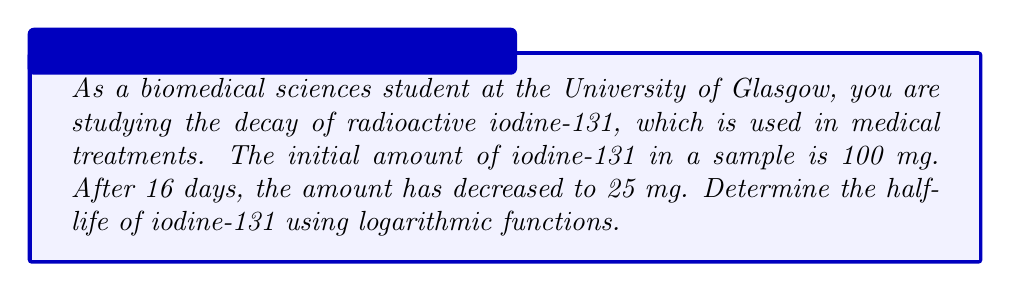Provide a solution to this math problem. To solve this problem, we'll use the exponential decay formula and logarithms:

1) The exponential decay formula is:
   $$A(t) = A_0 \cdot e^{-\lambda t}$$
   where $A(t)$ is the amount at time $t$, $A_0$ is the initial amount, $\lambda$ is the decay constant, and $t$ is time.

2) We know:
   $A_0 = 100$ mg
   $A(16) = 25$ mg
   $t = 16$ days

3) Substitute these values into the formula:
   $$25 = 100 \cdot e^{-16\lambda}$$

4) Divide both sides by 100:
   $$0.25 = e^{-16\lambda}$$

5) Take the natural logarithm of both sides:
   $$\ln(0.25) = -16\lambda$$

6) Solve for $\lambda$:
   $$\lambda = -\frac{\ln(0.25)}{16} = 0.0866$$

7) The half-life formula is:
   $$t_{1/2} = \frac{\ln(2)}{\lambda}$$

8) Substitute $\lambda$ and calculate:
   $$t_{1/2} = \frac{\ln(2)}{0.0866} = 8.01$$ days
Answer: The half-life of iodine-131 is approximately 8.01 days. 